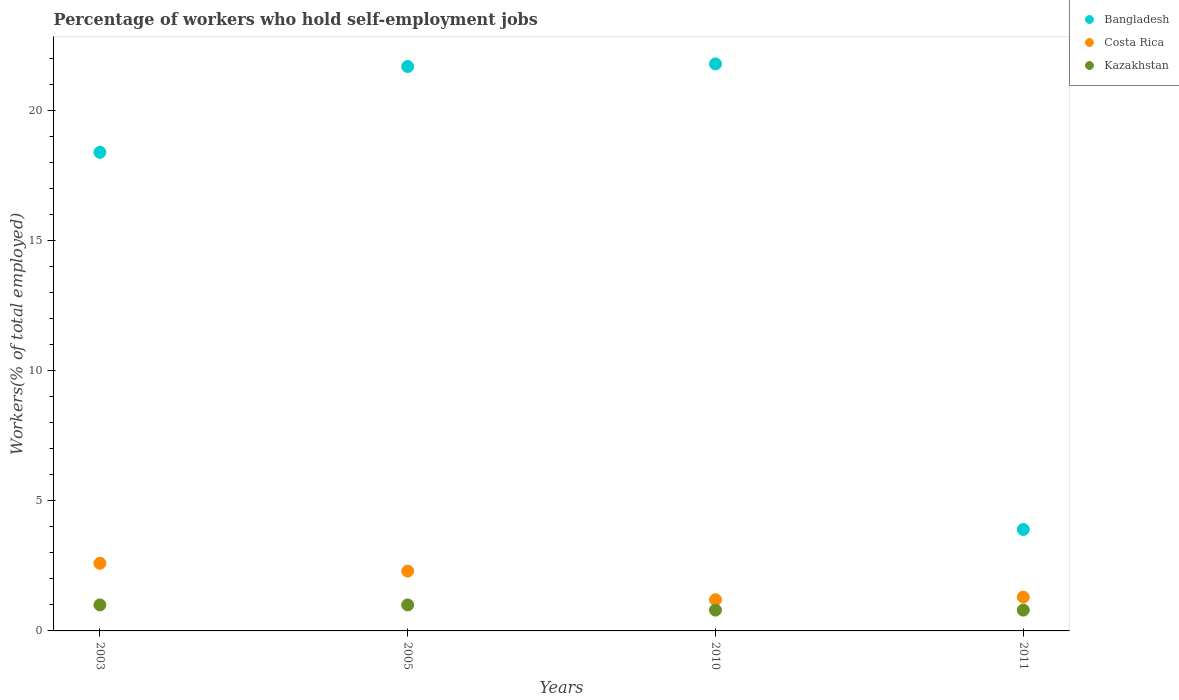What is the percentage of self-employed workers in Costa Rica in 2003?
Your answer should be compact. 2.6. Across all years, what is the maximum percentage of self-employed workers in Costa Rica?
Provide a short and direct response. 2.6. Across all years, what is the minimum percentage of self-employed workers in Kazakhstan?
Provide a succinct answer. 0.8. In which year was the percentage of self-employed workers in Costa Rica maximum?
Give a very brief answer. 2003. In which year was the percentage of self-employed workers in Costa Rica minimum?
Provide a short and direct response. 2010. What is the total percentage of self-employed workers in Kazakhstan in the graph?
Provide a short and direct response. 3.6. What is the difference between the percentage of self-employed workers in Bangladesh in 2005 and that in 2010?
Ensure brevity in your answer.  -0.1. What is the difference between the percentage of self-employed workers in Bangladesh in 2003 and the percentage of self-employed workers in Kazakhstan in 2010?
Give a very brief answer. 17.6. What is the average percentage of self-employed workers in Bangladesh per year?
Your answer should be compact. 16.45. In the year 2005, what is the difference between the percentage of self-employed workers in Bangladesh and percentage of self-employed workers in Kazakhstan?
Offer a very short reply. 20.7. In how many years, is the percentage of self-employed workers in Costa Rica greater than 21 %?
Your response must be concise. 0. What is the ratio of the percentage of self-employed workers in Bangladesh in 2005 to that in 2010?
Offer a very short reply. 1. Is the difference between the percentage of self-employed workers in Bangladesh in 2005 and 2011 greater than the difference between the percentage of self-employed workers in Kazakhstan in 2005 and 2011?
Provide a short and direct response. Yes. What is the difference between the highest and the lowest percentage of self-employed workers in Bangladesh?
Keep it short and to the point. 17.9. Does the percentage of self-employed workers in Kazakhstan monotonically increase over the years?
Give a very brief answer. No. Is the percentage of self-employed workers in Kazakhstan strictly greater than the percentage of self-employed workers in Costa Rica over the years?
Provide a succinct answer. No. Is the percentage of self-employed workers in Bangladesh strictly less than the percentage of self-employed workers in Costa Rica over the years?
Provide a short and direct response. No. What is the difference between two consecutive major ticks on the Y-axis?
Your answer should be compact. 5. Are the values on the major ticks of Y-axis written in scientific E-notation?
Provide a short and direct response. No. Does the graph contain any zero values?
Provide a short and direct response. No. Does the graph contain grids?
Keep it short and to the point. No. How many legend labels are there?
Keep it short and to the point. 3. How are the legend labels stacked?
Make the answer very short. Vertical. What is the title of the graph?
Provide a succinct answer. Percentage of workers who hold self-employment jobs. Does "Bolivia" appear as one of the legend labels in the graph?
Your response must be concise. No. What is the label or title of the X-axis?
Provide a short and direct response. Years. What is the label or title of the Y-axis?
Keep it short and to the point. Workers(% of total employed). What is the Workers(% of total employed) in Bangladesh in 2003?
Ensure brevity in your answer.  18.4. What is the Workers(% of total employed) of Costa Rica in 2003?
Ensure brevity in your answer.  2.6. What is the Workers(% of total employed) of Bangladesh in 2005?
Your answer should be compact. 21.7. What is the Workers(% of total employed) in Costa Rica in 2005?
Your response must be concise. 2.3. What is the Workers(% of total employed) of Bangladesh in 2010?
Make the answer very short. 21.8. What is the Workers(% of total employed) of Costa Rica in 2010?
Your answer should be compact. 1.2. What is the Workers(% of total employed) in Kazakhstan in 2010?
Your answer should be compact. 0.8. What is the Workers(% of total employed) of Bangladesh in 2011?
Keep it short and to the point. 3.9. What is the Workers(% of total employed) of Costa Rica in 2011?
Make the answer very short. 1.3. What is the Workers(% of total employed) of Kazakhstan in 2011?
Offer a very short reply. 0.8. Across all years, what is the maximum Workers(% of total employed) in Bangladesh?
Offer a terse response. 21.8. Across all years, what is the maximum Workers(% of total employed) of Costa Rica?
Offer a very short reply. 2.6. Across all years, what is the maximum Workers(% of total employed) of Kazakhstan?
Make the answer very short. 1. Across all years, what is the minimum Workers(% of total employed) of Bangladesh?
Keep it short and to the point. 3.9. Across all years, what is the minimum Workers(% of total employed) in Costa Rica?
Provide a succinct answer. 1.2. Across all years, what is the minimum Workers(% of total employed) of Kazakhstan?
Your answer should be very brief. 0.8. What is the total Workers(% of total employed) of Bangladesh in the graph?
Your answer should be very brief. 65.8. What is the total Workers(% of total employed) of Costa Rica in the graph?
Your response must be concise. 7.4. What is the difference between the Workers(% of total employed) of Bangladesh in 2003 and that in 2005?
Your response must be concise. -3.3. What is the difference between the Workers(% of total employed) in Kazakhstan in 2003 and that in 2005?
Ensure brevity in your answer.  0. What is the difference between the Workers(% of total employed) in Costa Rica in 2003 and that in 2010?
Ensure brevity in your answer.  1.4. What is the difference between the Workers(% of total employed) in Bangladesh in 2003 and that in 2011?
Offer a very short reply. 14.5. What is the difference between the Workers(% of total employed) of Costa Rica in 2003 and that in 2011?
Ensure brevity in your answer.  1.3. What is the difference between the Workers(% of total employed) in Bangladesh in 2005 and that in 2010?
Keep it short and to the point. -0.1. What is the difference between the Workers(% of total employed) in Costa Rica in 2010 and that in 2011?
Your answer should be compact. -0.1. What is the difference between the Workers(% of total employed) of Bangladesh in 2003 and the Workers(% of total employed) of Costa Rica in 2005?
Ensure brevity in your answer.  16.1. What is the difference between the Workers(% of total employed) of Bangladesh in 2003 and the Workers(% of total employed) of Kazakhstan in 2005?
Provide a short and direct response. 17.4. What is the difference between the Workers(% of total employed) of Costa Rica in 2003 and the Workers(% of total employed) of Kazakhstan in 2005?
Your response must be concise. 1.6. What is the difference between the Workers(% of total employed) of Bangladesh in 2003 and the Workers(% of total employed) of Kazakhstan in 2011?
Your response must be concise. 17.6. What is the difference between the Workers(% of total employed) of Costa Rica in 2003 and the Workers(% of total employed) of Kazakhstan in 2011?
Ensure brevity in your answer.  1.8. What is the difference between the Workers(% of total employed) of Bangladesh in 2005 and the Workers(% of total employed) of Kazakhstan in 2010?
Make the answer very short. 20.9. What is the difference between the Workers(% of total employed) in Costa Rica in 2005 and the Workers(% of total employed) in Kazakhstan in 2010?
Provide a short and direct response. 1.5. What is the difference between the Workers(% of total employed) in Bangladesh in 2005 and the Workers(% of total employed) in Costa Rica in 2011?
Make the answer very short. 20.4. What is the difference between the Workers(% of total employed) of Bangladesh in 2005 and the Workers(% of total employed) of Kazakhstan in 2011?
Give a very brief answer. 20.9. What is the difference between the Workers(% of total employed) of Costa Rica in 2010 and the Workers(% of total employed) of Kazakhstan in 2011?
Your answer should be compact. 0.4. What is the average Workers(% of total employed) of Bangladesh per year?
Ensure brevity in your answer.  16.45. What is the average Workers(% of total employed) of Costa Rica per year?
Give a very brief answer. 1.85. In the year 2003, what is the difference between the Workers(% of total employed) of Bangladesh and Workers(% of total employed) of Kazakhstan?
Keep it short and to the point. 17.4. In the year 2003, what is the difference between the Workers(% of total employed) of Costa Rica and Workers(% of total employed) of Kazakhstan?
Give a very brief answer. 1.6. In the year 2005, what is the difference between the Workers(% of total employed) in Bangladesh and Workers(% of total employed) in Kazakhstan?
Your response must be concise. 20.7. In the year 2005, what is the difference between the Workers(% of total employed) of Costa Rica and Workers(% of total employed) of Kazakhstan?
Keep it short and to the point. 1.3. In the year 2010, what is the difference between the Workers(% of total employed) in Bangladesh and Workers(% of total employed) in Costa Rica?
Make the answer very short. 20.6. In the year 2010, what is the difference between the Workers(% of total employed) of Costa Rica and Workers(% of total employed) of Kazakhstan?
Your answer should be very brief. 0.4. In the year 2011, what is the difference between the Workers(% of total employed) in Bangladesh and Workers(% of total employed) in Costa Rica?
Offer a terse response. 2.6. In the year 2011, what is the difference between the Workers(% of total employed) in Bangladesh and Workers(% of total employed) in Kazakhstan?
Make the answer very short. 3.1. In the year 2011, what is the difference between the Workers(% of total employed) of Costa Rica and Workers(% of total employed) of Kazakhstan?
Keep it short and to the point. 0.5. What is the ratio of the Workers(% of total employed) in Bangladesh in 2003 to that in 2005?
Offer a terse response. 0.85. What is the ratio of the Workers(% of total employed) of Costa Rica in 2003 to that in 2005?
Provide a succinct answer. 1.13. What is the ratio of the Workers(% of total employed) of Kazakhstan in 2003 to that in 2005?
Your response must be concise. 1. What is the ratio of the Workers(% of total employed) in Bangladesh in 2003 to that in 2010?
Your response must be concise. 0.84. What is the ratio of the Workers(% of total employed) of Costa Rica in 2003 to that in 2010?
Offer a very short reply. 2.17. What is the ratio of the Workers(% of total employed) in Bangladesh in 2003 to that in 2011?
Make the answer very short. 4.72. What is the ratio of the Workers(% of total employed) of Costa Rica in 2005 to that in 2010?
Keep it short and to the point. 1.92. What is the ratio of the Workers(% of total employed) in Kazakhstan in 2005 to that in 2010?
Offer a terse response. 1.25. What is the ratio of the Workers(% of total employed) of Bangladesh in 2005 to that in 2011?
Provide a short and direct response. 5.56. What is the ratio of the Workers(% of total employed) of Costa Rica in 2005 to that in 2011?
Give a very brief answer. 1.77. What is the ratio of the Workers(% of total employed) of Bangladesh in 2010 to that in 2011?
Ensure brevity in your answer.  5.59. What is the ratio of the Workers(% of total employed) of Kazakhstan in 2010 to that in 2011?
Make the answer very short. 1. What is the difference between the highest and the second highest Workers(% of total employed) in Bangladesh?
Give a very brief answer. 0.1. What is the difference between the highest and the lowest Workers(% of total employed) of Costa Rica?
Provide a succinct answer. 1.4. What is the difference between the highest and the lowest Workers(% of total employed) of Kazakhstan?
Provide a succinct answer. 0.2. 